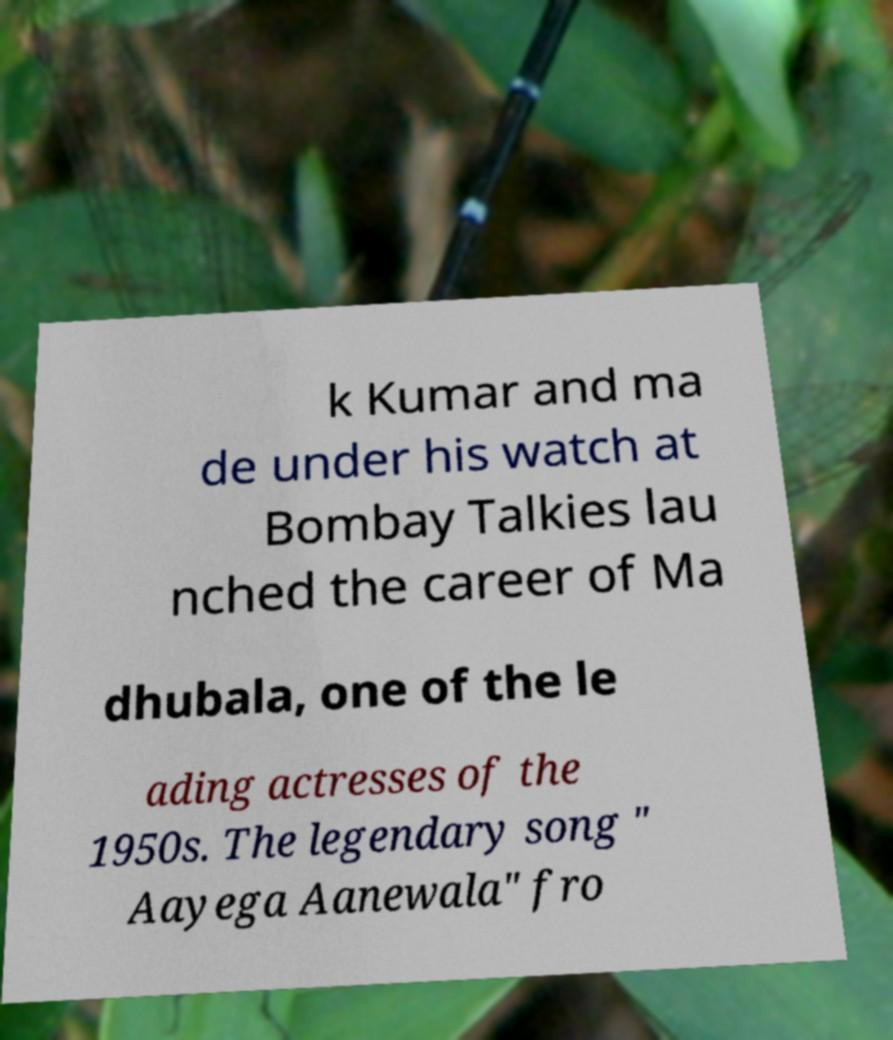Could you assist in decoding the text presented in this image and type it out clearly? k Kumar and ma de under his watch at Bombay Talkies lau nched the career of Ma dhubala, one of the le ading actresses of the 1950s. The legendary song " Aayega Aanewala" fro 